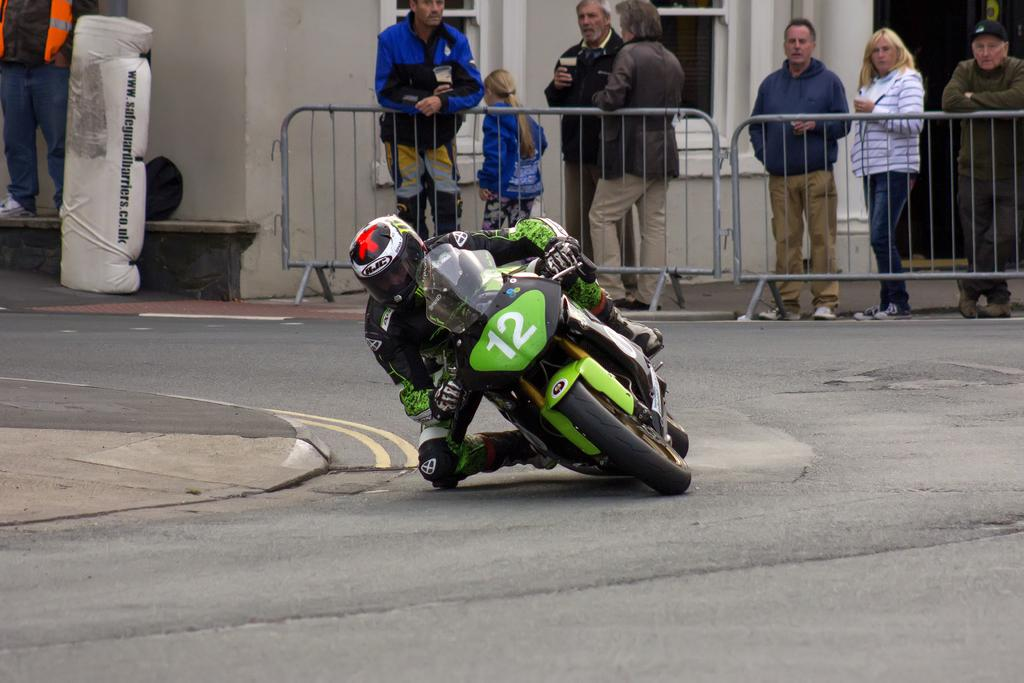What is the main feature of the image? There is a road in the image. What is the person on the road doing? A person is riding a bike on the road. What type of barrier is present in the image? There is an iron fencing in the image. Who is observing the scene? People are observing from the iron fencing. What might be happening in the image? The scene appears to be a race. What type of base is used for the holiday decorations in the image? There are no holiday decorations present in the image. Who is leading the race in the image? There is no indication of a race leader in the image, as it only shows a person riding a bike and people observing. 